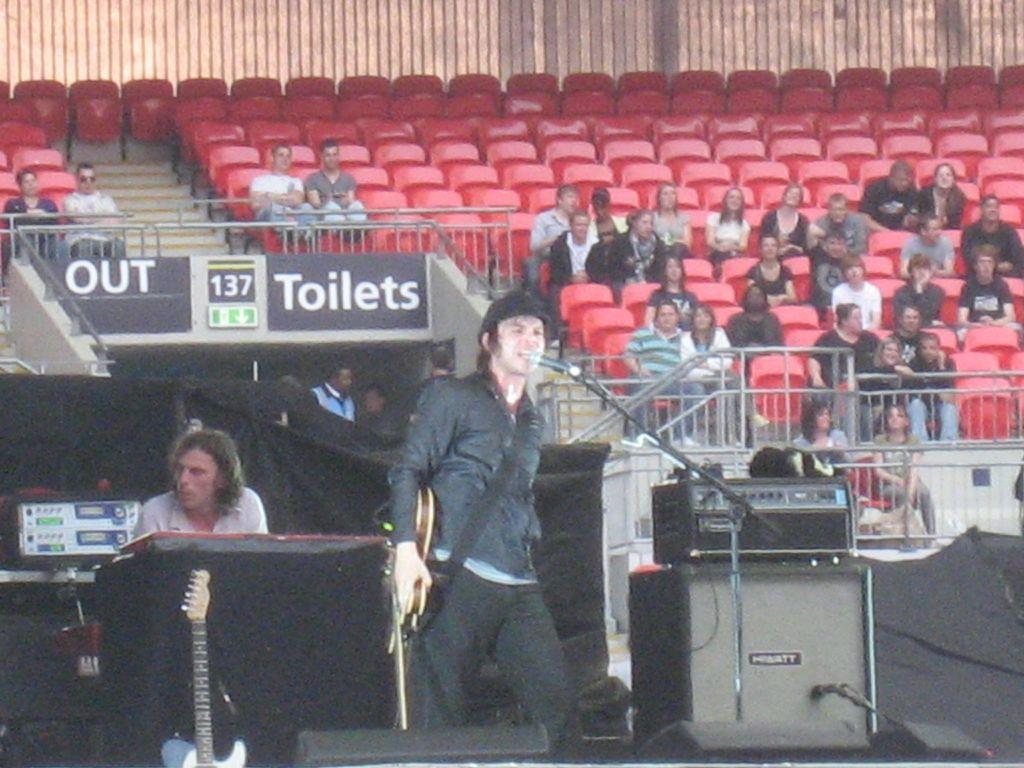Describe this image in one or two sentences. In this picture we can see a man who is standing in front of mike and singing. Here one person is sitting and in the background we can see red color chairs. And some people are sitting here. And this is the wall. 